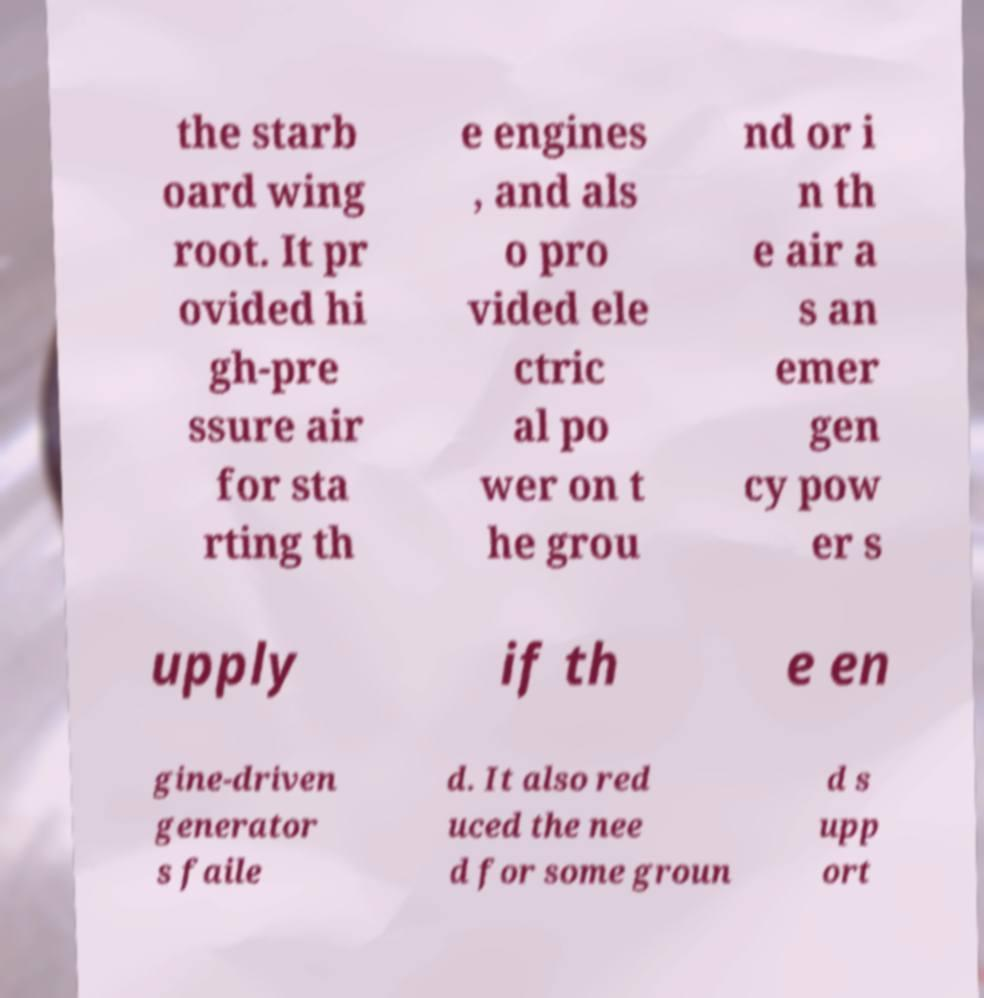I need the written content from this picture converted into text. Can you do that? the starb oard wing root. It pr ovided hi gh-pre ssure air for sta rting th e engines , and als o pro vided ele ctric al po wer on t he grou nd or i n th e air a s an emer gen cy pow er s upply if th e en gine-driven generator s faile d. It also red uced the nee d for some groun d s upp ort 